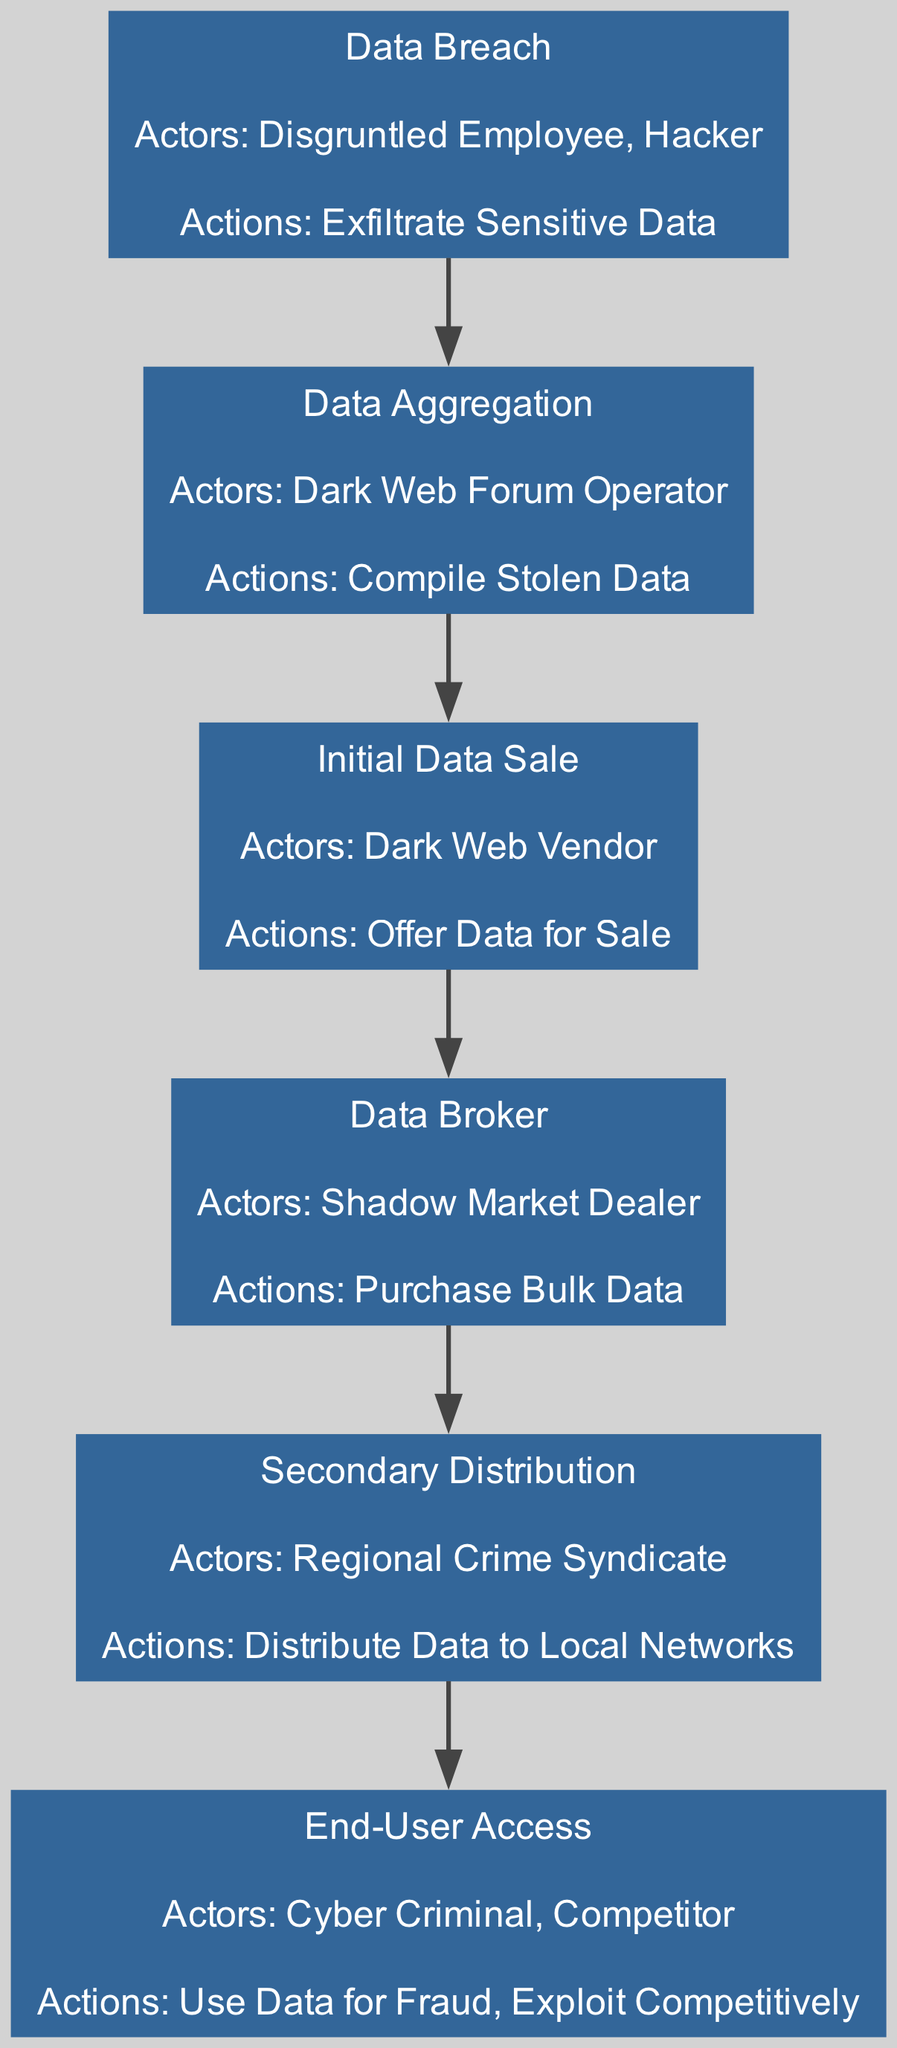What is the first stage in the supply chain? The diagram lists the stages sequentially, and the first stage is specifically labeled as "Data Breach."
Answer: Data Breach Who are the actors involved in the "End-User Access" stage? This stage is connected to the elements in the diagram, and the actors specifically listed for this stage are "Cyber Criminal" and "Competitor."
Answer: Cyber Criminal, Competitor How many distinct stages are there in the supply chain? By counting each labeled stage in the diagram, we find there are six unique stages illustrated from start to finish.
Answer: 6 What action is taken in the "Data Aggregation" stage? The diagram specifies that the action associated with the "Data Aggregation" stage is "Compile Stolen Data."
Answer: Compile Stolen Data Which actor purchases bulk data, according to the diagram? In the "Data Broker" stage, the actor responsible for purchasing bulk data is identified as "Shadow Market Dealer."
Answer: Shadow Market Dealer What is the last action performed in the supply chain? The "End-User Access" stage contains two actions, and the last one listed is "Exploit Competitively."
Answer: Exploit Competitively How does data flow from "Data Breach" to "Data Aggregation"? The diagram shows a direct edge connecting these two stages, indicating a sequential flow from "Data Breach" to "Data Aggregation."
Answer: Direct edge What are the two actions listed under the "End-User Access"? The actions detailed in this stage include "Use Data for Fraud" and "Exploit Competitively."
Answer: Use Data for Fraud, Exploit Competitively Which stage involves the "Regional Crime Syndicate"? The actor "Regional Crime Syndicate" is listed under the "Secondary Distribution" stage, hence it pertains to this particular stage in the flow.
Answer: Secondary Distribution 